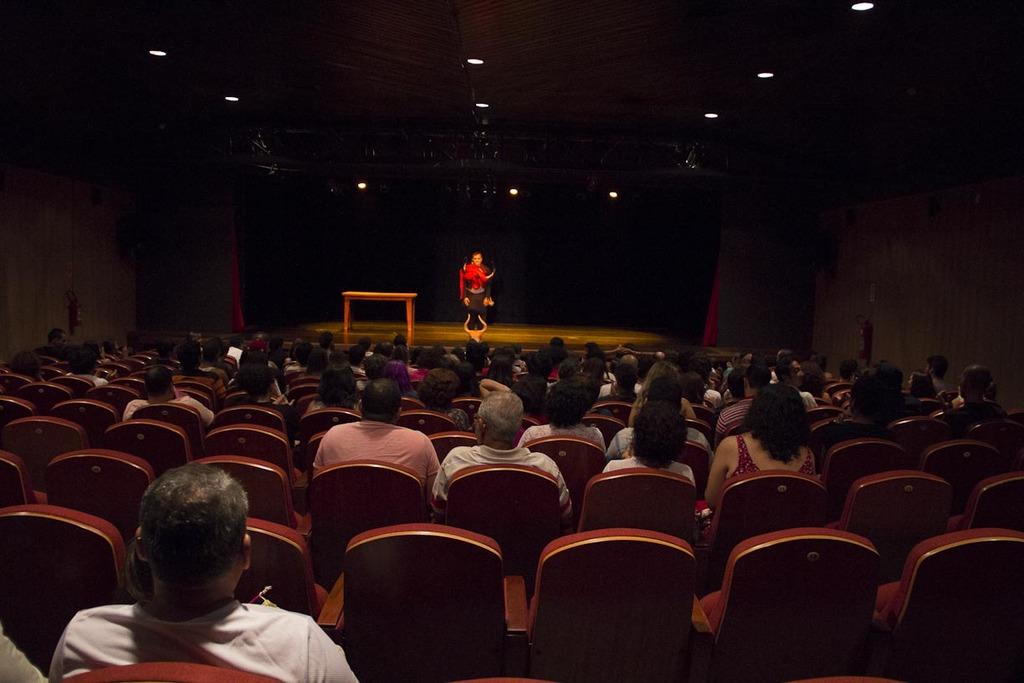What is happening on the stage in the image? There is a person on the stage in the image. Where are the people in the image primarily located? The people are sitting in chairs in front of the stage. What can be seen on the roof in the image? There are lights on the roof in the image. What is present on the stage besides the person? There is a table on the stage in the image. What type of vessel is being used to transport bricks in the image? There is no vessel or bricks present in the image. What time of day is it in the image, considering the morning? The time of day cannot be determined from the image, as there is no indication of the time or the presence of morning. 